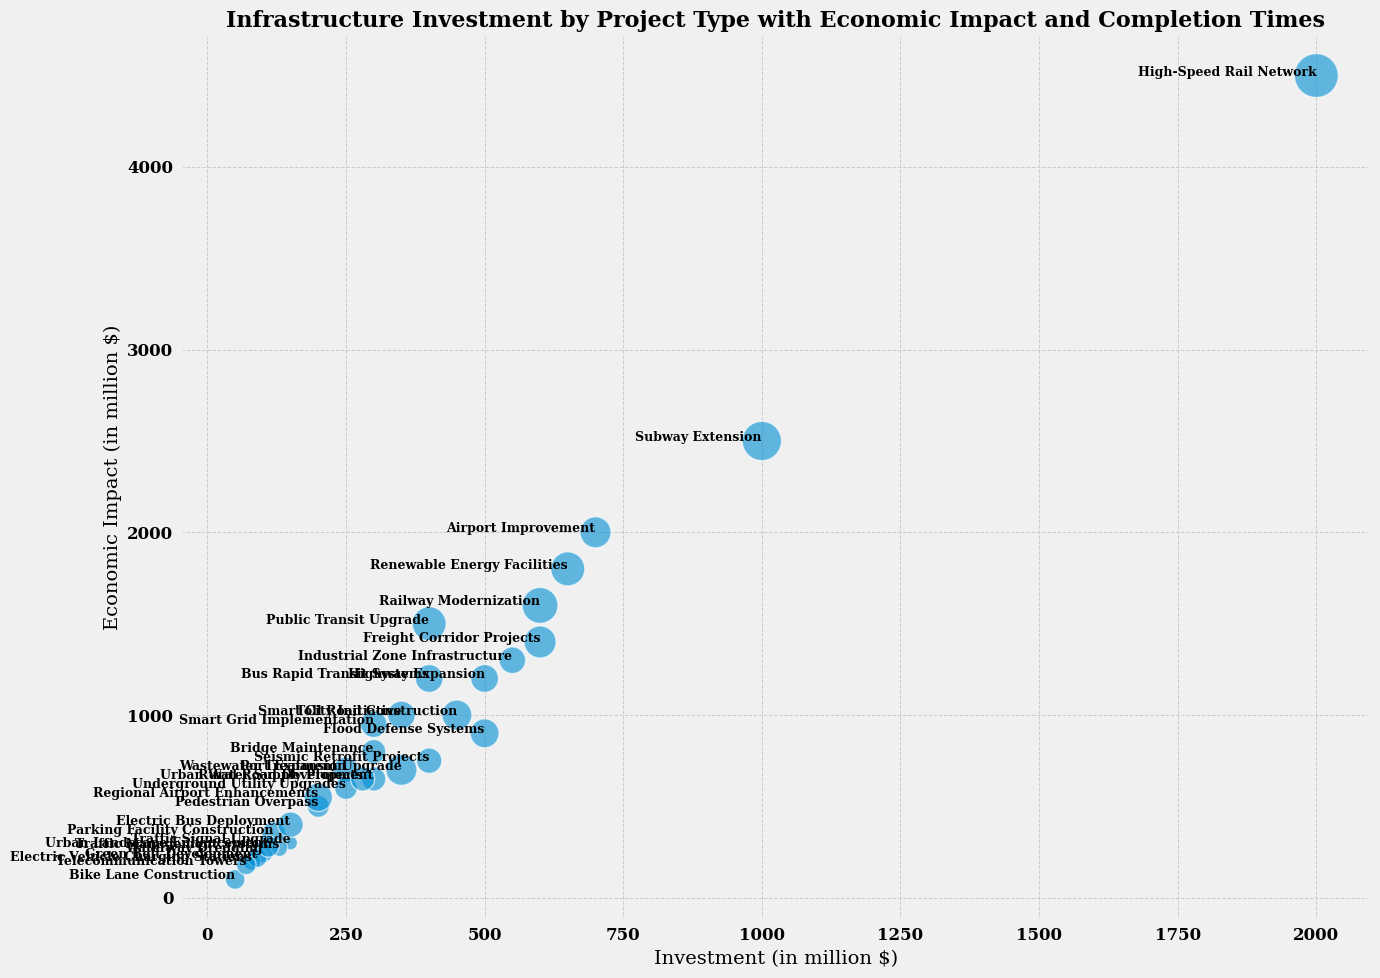Which project type has the highest economic impact? To find the project type with the highest economic impact, look for the largest value on the y-axis. The High-Speed Rail Network has an economic impact of $4500 million, the largest value on the y-axis.
Answer: High-Speed Rail Network Which project type has the shortest completion time? To determine the project type with the shortest completion time, find the smallest marker size. The Traffic Signal Upgrade has the smallest marker, with a completion time of 6 months.
Answer: Traffic Signal Upgrade Which project type requires the largest investment? Locate the project type with the furthest right position along the x-axis. The High-Speed Rail Network requires the largest investment, which is $2000 million.
Answer: High-Speed Rail Network How does the completion time for Highway Expansion compare to that of Subway Extension? Observe the relative sizes of the markers for these project types. Highway Expansion has a smaller marker representing 24 months, while Subway Extension has a larger marker representing 48 months.
Answer: Highway Expansion has a shorter completion time What’s the total economic impact of all projects where the completion time is less than 20 months? Sum the economic impacts for the projects with completion times less than 20 months: Bike Lane Construction ($100 million), Traffic Signal Upgrade ($300 million), Electric Vehicle Charging Stations ($200 million), Ports Expansion ($700 million), Pedestrian Overpass ($500 million), Park Facility Construction ($350 million), Rural Road Development ($650 million), Urban Landscape Enhancement ($280 million), Telecommunication Towers ($180 million). The total is 100 + 300 + 200 + 700 + 500 + 350 + 650 + 280 + 180 = $3260 million
Answer: $3260 million Which has a higher economic impact per investment dollar, Public Transit Upgrade or Renewable Energy Facilities? Calculate the economic impact per investment dollar: 
- Public Transit Upgrade: $1500 million / $400 million = 3.75
- Renewable Energy Facilities: $1800 million / $650 million = 2.77
Public Transit Upgrade has a higher economic impact per investment dollar.
Answer: Public Transit Upgrade Are there more projects with completion times less than 12 months or greater than 30 months? Count the number of projects in each category: 
- Less than 12 months: Bike Lane Construction, Traffic Signal Upgrade, Electric Vehicle Charging Stations, Urban Landscape Enhancement, Telecommunication Towers, Green Belt Development (Total: 6)
- Greater than 30 months: Public Transit Upgrade, Subway Extension, Railway Modernization, High-Speed Rail Network, Bus Rapid Transit Systems, Wastewater Treatment Upgrade (Total: 6)
Both categories have the same number of projects.
Answer: Equal Which project type has the smallest economic impact for an investment greater than $300 million? Identify projects with an investment greater than $300 million and assess their economic impact: 
- Highway Expansion ($1200 million)
- Public Transit Upgrade ($1500 million)
- Subway Extension ($2500 million)
- Airport Improvement ($2000 million)
- Railway Modernization ($1600 million)
- Renewable Energy Facilities ($1800 million)
- High-Speed Rail Network ($4500 million)
- Freight Corridor Projects ($1400 million)
- Industrial Zone Infrastructure ($1300 million)
- Seismic Retrofit Projects ($750 million)
- Smart Grid Implementation ($950 million)
- Toll Road Construction ($1000 million)
Seismic Retrofit Projects has the smallest economic impact at $750 million.
Answer: Seismic Retrofit Projects 